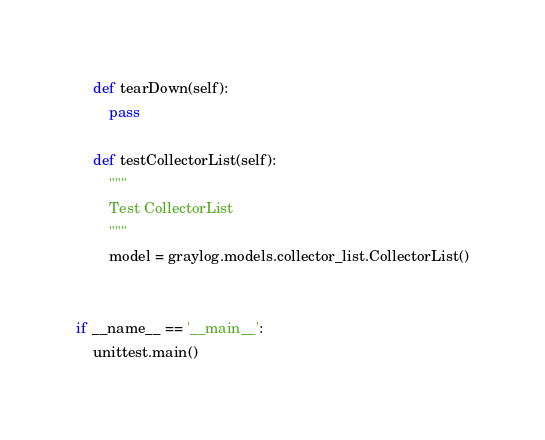Convert code to text. <code><loc_0><loc_0><loc_500><loc_500><_Python_>
    def tearDown(self):
        pass

    def testCollectorList(self):
        """
        Test CollectorList
        """
        model = graylog.models.collector_list.CollectorList()


if __name__ == '__main__':
    unittest.main()
</code> 